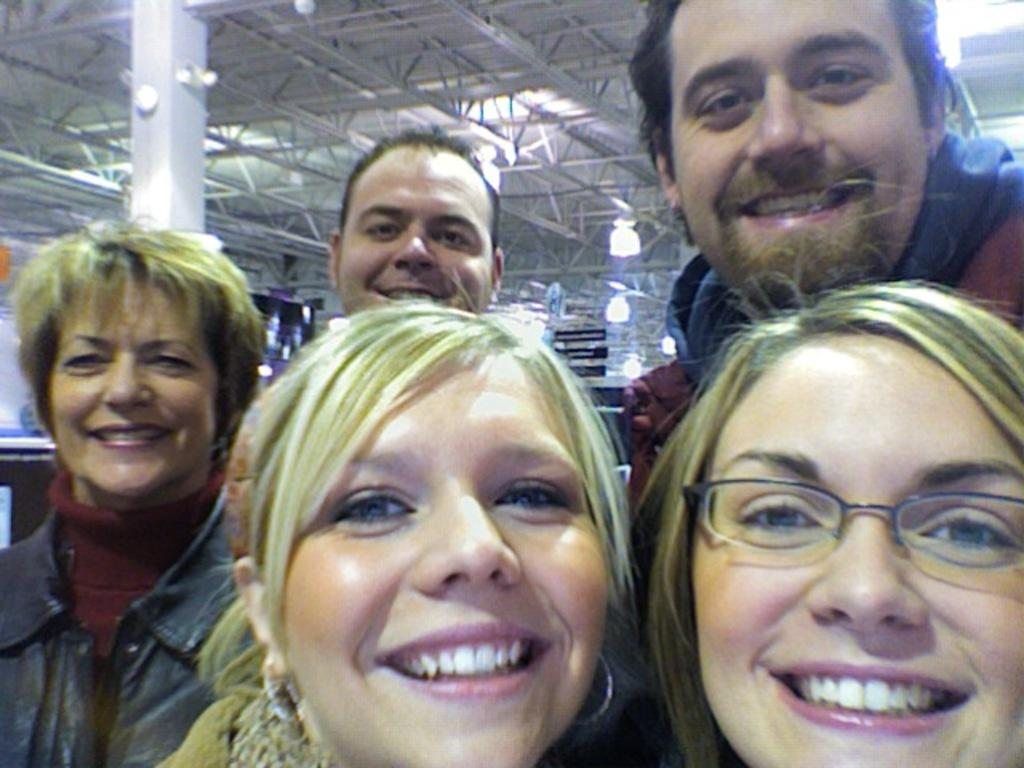How many people are in the image? There are five people in the image. What are the people doing in the image? The people are standing and laughing. What can be seen in the background of the image? There is a pole, a roof with iron frames, and lights attached to the ceiling in the background of the image. What is the name of the sheep in the image? There are no sheep present in the image. Where is the hall located in the image? The image does not depict a hall; it shows five people standing and laughing with a specific background. 